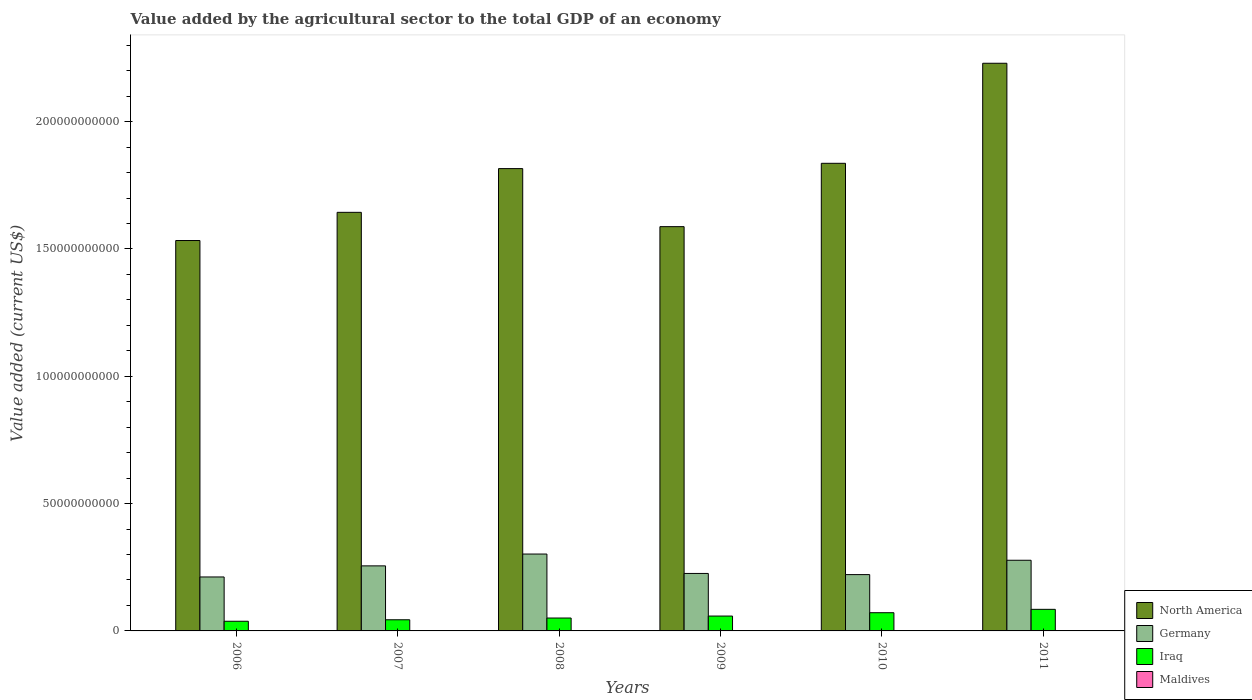How many bars are there on the 3rd tick from the right?
Your answer should be compact. 4. What is the value added by the agricultural sector to the total GDP in Maldives in 2008?
Keep it short and to the point. 1.07e+08. Across all years, what is the maximum value added by the agricultural sector to the total GDP in Iraq?
Provide a succinct answer. 8.48e+09. Across all years, what is the minimum value added by the agricultural sector to the total GDP in Maldives?
Your response must be concise. 8.38e+07. In which year was the value added by the agricultural sector to the total GDP in Germany maximum?
Give a very brief answer. 2008. In which year was the value added by the agricultural sector to the total GDP in North America minimum?
Your response must be concise. 2006. What is the total value added by the agricultural sector to the total GDP in North America in the graph?
Give a very brief answer. 1.06e+12. What is the difference between the value added by the agricultural sector to the total GDP in Germany in 2007 and that in 2010?
Offer a very short reply. 3.43e+09. What is the difference between the value added by the agricultural sector to the total GDP in North America in 2011 and the value added by the agricultural sector to the total GDP in Iraq in 2009?
Provide a succinct answer. 2.17e+11. What is the average value added by the agricultural sector to the total GDP in Iraq per year?
Make the answer very short. 5.78e+09. In the year 2007, what is the difference between the value added by the agricultural sector to the total GDP in Germany and value added by the agricultural sector to the total GDP in North America?
Keep it short and to the point. -1.39e+11. In how many years, is the value added by the agricultural sector to the total GDP in Germany greater than 120000000000 US$?
Provide a succinct answer. 0. What is the ratio of the value added by the agricultural sector to the total GDP in Maldives in 2007 to that in 2008?
Your answer should be compact. 0.81. Is the value added by the agricultural sector to the total GDP in Maldives in 2009 less than that in 2011?
Provide a short and direct response. Yes. What is the difference between the highest and the second highest value added by the agricultural sector to the total GDP in Iraq?
Ensure brevity in your answer.  1.33e+09. What is the difference between the highest and the lowest value added by the agricultural sector to the total GDP in Germany?
Offer a terse response. 9.01e+09. In how many years, is the value added by the agricultural sector to the total GDP in North America greater than the average value added by the agricultural sector to the total GDP in North America taken over all years?
Ensure brevity in your answer.  3. Is the sum of the value added by the agricultural sector to the total GDP in Germany in 2007 and 2011 greater than the maximum value added by the agricultural sector to the total GDP in Iraq across all years?
Your response must be concise. Yes. What does the 4th bar from the left in 2008 represents?
Ensure brevity in your answer.  Maldives. What does the 2nd bar from the right in 2011 represents?
Give a very brief answer. Iraq. Is it the case that in every year, the sum of the value added by the agricultural sector to the total GDP in Maldives and value added by the agricultural sector to the total GDP in Iraq is greater than the value added by the agricultural sector to the total GDP in North America?
Keep it short and to the point. No. How many bars are there?
Offer a very short reply. 24. Are all the bars in the graph horizontal?
Offer a terse response. No. What is the difference between two consecutive major ticks on the Y-axis?
Ensure brevity in your answer.  5.00e+1. Are the values on the major ticks of Y-axis written in scientific E-notation?
Offer a very short reply. No. Does the graph contain grids?
Make the answer very short. No. Where does the legend appear in the graph?
Provide a succinct answer. Bottom right. How are the legend labels stacked?
Make the answer very short. Vertical. What is the title of the graph?
Offer a terse response. Value added by the agricultural sector to the total GDP of an economy. What is the label or title of the X-axis?
Provide a succinct answer. Years. What is the label or title of the Y-axis?
Offer a terse response. Value added (current US$). What is the Value added (current US$) of North America in 2006?
Ensure brevity in your answer.  1.53e+11. What is the Value added (current US$) of Germany in 2006?
Keep it short and to the point. 2.12e+1. What is the Value added (current US$) of Iraq in 2006?
Make the answer very short. 3.80e+09. What is the Value added (current US$) of Maldives in 2006?
Your response must be concise. 8.38e+07. What is the Value added (current US$) in North America in 2007?
Your answer should be very brief. 1.64e+11. What is the Value added (current US$) in Germany in 2007?
Make the answer very short. 2.56e+1. What is the Value added (current US$) of Iraq in 2007?
Provide a succinct answer. 4.38e+09. What is the Value added (current US$) of Maldives in 2007?
Your answer should be very brief. 8.70e+07. What is the Value added (current US$) in North America in 2008?
Give a very brief answer. 1.82e+11. What is the Value added (current US$) of Germany in 2008?
Offer a terse response. 3.02e+1. What is the Value added (current US$) in Iraq in 2008?
Ensure brevity in your answer.  5.06e+09. What is the Value added (current US$) in Maldives in 2008?
Keep it short and to the point. 1.07e+08. What is the Value added (current US$) of North America in 2009?
Provide a short and direct response. 1.59e+11. What is the Value added (current US$) in Germany in 2009?
Give a very brief answer. 2.26e+1. What is the Value added (current US$) of Iraq in 2009?
Provide a short and direct response. 5.84e+09. What is the Value added (current US$) in Maldives in 2009?
Offer a very short reply. 8.56e+07. What is the Value added (current US$) of North America in 2010?
Keep it short and to the point. 1.84e+11. What is the Value added (current US$) of Germany in 2010?
Make the answer very short. 2.21e+1. What is the Value added (current US$) of Iraq in 2010?
Make the answer very short. 7.15e+09. What is the Value added (current US$) in Maldives in 2010?
Make the answer very short. 9.22e+07. What is the Value added (current US$) of North America in 2011?
Keep it short and to the point. 2.23e+11. What is the Value added (current US$) of Germany in 2011?
Ensure brevity in your answer.  2.78e+1. What is the Value added (current US$) of Iraq in 2011?
Provide a short and direct response. 8.48e+09. What is the Value added (current US$) in Maldives in 2011?
Give a very brief answer. 8.92e+07. Across all years, what is the maximum Value added (current US$) of North America?
Your response must be concise. 2.23e+11. Across all years, what is the maximum Value added (current US$) in Germany?
Make the answer very short. 3.02e+1. Across all years, what is the maximum Value added (current US$) in Iraq?
Your answer should be compact. 8.48e+09. Across all years, what is the maximum Value added (current US$) in Maldives?
Your answer should be very brief. 1.07e+08. Across all years, what is the minimum Value added (current US$) in North America?
Keep it short and to the point. 1.53e+11. Across all years, what is the minimum Value added (current US$) in Germany?
Keep it short and to the point. 2.12e+1. Across all years, what is the minimum Value added (current US$) in Iraq?
Provide a succinct answer. 3.80e+09. Across all years, what is the minimum Value added (current US$) in Maldives?
Offer a terse response. 8.38e+07. What is the total Value added (current US$) of North America in the graph?
Ensure brevity in your answer.  1.06e+12. What is the total Value added (current US$) in Germany in the graph?
Your response must be concise. 1.49e+11. What is the total Value added (current US$) in Iraq in the graph?
Your answer should be very brief. 3.47e+1. What is the total Value added (current US$) of Maldives in the graph?
Give a very brief answer. 5.45e+08. What is the difference between the Value added (current US$) in North America in 2006 and that in 2007?
Your answer should be compact. -1.11e+1. What is the difference between the Value added (current US$) in Germany in 2006 and that in 2007?
Ensure brevity in your answer.  -4.36e+09. What is the difference between the Value added (current US$) of Iraq in 2006 and that in 2007?
Give a very brief answer. -5.84e+08. What is the difference between the Value added (current US$) of Maldives in 2006 and that in 2007?
Make the answer very short. -3.25e+06. What is the difference between the Value added (current US$) in North America in 2006 and that in 2008?
Your answer should be compact. -2.82e+1. What is the difference between the Value added (current US$) in Germany in 2006 and that in 2008?
Keep it short and to the point. -9.01e+09. What is the difference between the Value added (current US$) of Iraq in 2006 and that in 2008?
Keep it short and to the point. -1.27e+09. What is the difference between the Value added (current US$) in Maldives in 2006 and that in 2008?
Your answer should be compact. -2.32e+07. What is the difference between the Value added (current US$) of North America in 2006 and that in 2009?
Give a very brief answer. -5.45e+09. What is the difference between the Value added (current US$) in Germany in 2006 and that in 2009?
Offer a very short reply. -1.38e+09. What is the difference between the Value added (current US$) in Iraq in 2006 and that in 2009?
Your response must be concise. -2.04e+09. What is the difference between the Value added (current US$) of Maldives in 2006 and that in 2009?
Give a very brief answer. -1.81e+06. What is the difference between the Value added (current US$) of North America in 2006 and that in 2010?
Make the answer very short. -3.03e+1. What is the difference between the Value added (current US$) of Germany in 2006 and that in 2010?
Offer a terse response. -9.29e+08. What is the difference between the Value added (current US$) in Iraq in 2006 and that in 2010?
Offer a very short reply. -3.36e+09. What is the difference between the Value added (current US$) in Maldives in 2006 and that in 2010?
Your response must be concise. -8.39e+06. What is the difference between the Value added (current US$) of North America in 2006 and that in 2011?
Ensure brevity in your answer.  -6.96e+1. What is the difference between the Value added (current US$) in Germany in 2006 and that in 2011?
Ensure brevity in your answer.  -6.56e+09. What is the difference between the Value added (current US$) in Iraq in 2006 and that in 2011?
Offer a very short reply. -4.68e+09. What is the difference between the Value added (current US$) of Maldives in 2006 and that in 2011?
Offer a terse response. -5.36e+06. What is the difference between the Value added (current US$) in North America in 2007 and that in 2008?
Keep it short and to the point. -1.72e+1. What is the difference between the Value added (current US$) of Germany in 2007 and that in 2008?
Your response must be concise. -4.65e+09. What is the difference between the Value added (current US$) in Iraq in 2007 and that in 2008?
Your answer should be compact. -6.85e+08. What is the difference between the Value added (current US$) in Maldives in 2007 and that in 2008?
Your answer should be very brief. -2.00e+07. What is the difference between the Value added (current US$) in North America in 2007 and that in 2009?
Offer a terse response. 5.62e+09. What is the difference between the Value added (current US$) of Germany in 2007 and that in 2009?
Offer a very short reply. 2.98e+09. What is the difference between the Value added (current US$) of Iraq in 2007 and that in 2009?
Ensure brevity in your answer.  -1.46e+09. What is the difference between the Value added (current US$) of Maldives in 2007 and that in 2009?
Give a very brief answer. 1.43e+06. What is the difference between the Value added (current US$) of North America in 2007 and that in 2010?
Give a very brief answer. -1.93e+1. What is the difference between the Value added (current US$) of Germany in 2007 and that in 2010?
Offer a very short reply. 3.43e+09. What is the difference between the Value added (current US$) in Iraq in 2007 and that in 2010?
Give a very brief answer. -2.77e+09. What is the difference between the Value added (current US$) in Maldives in 2007 and that in 2010?
Make the answer very short. -5.14e+06. What is the difference between the Value added (current US$) of North America in 2007 and that in 2011?
Ensure brevity in your answer.  -5.85e+1. What is the difference between the Value added (current US$) of Germany in 2007 and that in 2011?
Keep it short and to the point. -2.20e+09. What is the difference between the Value added (current US$) in Iraq in 2007 and that in 2011?
Ensure brevity in your answer.  -4.10e+09. What is the difference between the Value added (current US$) of Maldives in 2007 and that in 2011?
Give a very brief answer. -2.12e+06. What is the difference between the Value added (current US$) in North America in 2008 and that in 2009?
Keep it short and to the point. 2.28e+1. What is the difference between the Value added (current US$) of Germany in 2008 and that in 2009?
Offer a very short reply. 7.62e+09. What is the difference between the Value added (current US$) in Iraq in 2008 and that in 2009?
Ensure brevity in your answer.  -7.76e+08. What is the difference between the Value added (current US$) in Maldives in 2008 and that in 2009?
Your response must be concise. 2.14e+07. What is the difference between the Value added (current US$) of North America in 2008 and that in 2010?
Your answer should be very brief. -2.08e+09. What is the difference between the Value added (current US$) of Germany in 2008 and that in 2010?
Your answer should be compact. 8.08e+09. What is the difference between the Value added (current US$) of Iraq in 2008 and that in 2010?
Provide a succinct answer. -2.09e+09. What is the difference between the Value added (current US$) of Maldives in 2008 and that in 2010?
Keep it short and to the point. 1.48e+07. What is the difference between the Value added (current US$) in North America in 2008 and that in 2011?
Keep it short and to the point. -4.14e+1. What is the difference between the Value added (current US$) in Germany in 2008 and that in 2011?
Provide a short and direct response. 2.44e+09. What is the difference between the Value added (current US$) in Iraq in 2008 and that in 2011?
Offer a terse response. -3.41e+09. What is the difference between the Value added (current US$) of Maldives in 2008 and that in 2011?
Make the answer very short. 1.79e+07. What is the difference between the Value added (current US$) in North America in 2009 and that in 2010?
Your answer should be compact. -2.49e+1. What is the difference between the Value added (current US$) in Germany in 2009 and that in 2010?
Provide a short and direct response. 4.54e+08. What is the difference between the Value added (current US$) of Iraq in 2009 and that in 2010?
Your answer should be compact. -1.31e+09. What is the difference between the Value added (current US$) of Maldives in 2009 and that in 2010?
Make the answer very short. -6.58e+06. What is the difference between the Value added (current US$) of North America in 2009 and that in 2011?
Your response must be concise. -6.42e+1. What is the difference between the Value added (current US$) in Germany in 2009 and that in 2011?
Offer a terse response. -5.18e+09. What is the difference between the Value added (current US$) in Iraq in 2009 and that in 2011?
Provide a short and direct response. -2.64e+09. What is the difference between the Value added (current US$) in Maldives in 2009 and that in 2011?
Offer a terse response. -3.55e+06. What is the difference between the Value added (current US$) of North America in 2010 and that in 2011?
Offer a very short reply. -3.93e+1. What is the difference between the Value added (current US$) in Germany in 2010 and that in 2011?
Your answer should be very brief. -5.64e+09. What is the difference between the Value added (current US$) of Iraq in 2010 and that in 2011?
Your response must be concise. -1.33e+09. What is the difference between the Value added (current US$) in Maldives in 2010 and that in 2011?
Offer a very short reply. 3.03e+06. What is the difference between the Value added (current US$) in North America in 2006 and the Value added (current US$) in Germany in 2007?
Keep it short and to the point. 1.28e+11. What is the difference between the Value added (current US$) of North America in 2006 and the Value added (current US$) of Iraq in 2007?
Make the answer very short. 1.49e+11. What is the difference between the Value added (current US$) of North America in 2006 and the Value added (current US$) of Maldives in 2007?
Give a very brief answer. 1.53e+11. What is the difference between the Value added (current US$) in Germany in 2006 and the Value added (current US$) in Iraq in 2007?
Your response must be concise. 1.68e+1. What is the difference between the Value added (current US$) of Germany in 2006 and the Value added (current US$) of Maldives in 2007?
Ensure brevity in your answer.  2.11e+1. What is the difference between the Value added (current US$) in Iraq in 2006 and the Value added (current US$) in Maldives in 2007?
Your answer should be very brief. 3.71e+09. What is the difference between the Value added (current US$) of North America in 2006 and the Value added (current US$) of Germany in 2008?
Your response must be concise. 1.23e+11. What is the difference between the Value added (current US$) of North America in 2006 and the Value added (current US$) of Iraq in 2008?
Give a very brief answer. 1.48e+11. What is the difference between the Value added (current US$) of North America in 2006 and the Value added (current US$) of Maldives in 2008?
Make the answer very short. 1.53e+11. What is the difference between the Value added (current US$) in Germany in 2006 and the Value added (current US$) in Iraq in 2008?
Make the answer very short. 1.61e+1. What is the difference between the Value added (current US$) in Germany in 2006 and the Value added (current US$) in Maldives in 2008?
Your response must be concise. 2.11e+1. What is the difference between the Value added (current US$) of Iraq in 2006 and the Value added (current US$) of Maldives in 2008?
Keep it short and to the point. 3.69e+09. What is the difference between the Value added (current US$) of North America in 2006 and the Value added (current US$) of Germany in 2009?
Offer a very short reply. 1.31e+11. What is the difference between the Value added (current US$) of North America in 2006 and the Value added (current US$) of Iraq in 2009?
Your answer should be very brief. 1.47e+11. What is the difference between the Value added (current US$) of North America in 2006 and the Value added (current US$) of Maldives in 2009?
Give a very brief answer. 1.53e+11. What is the difference between the Value added (current US$) of Germany in 2006 and the Value added (current US$) of Iraq in 2009?
Your answer should be very brief. 1.54e+1. What is the difference between the Value added (current US$) in Germany in 2006 and the Value added (current US$) in Maldives in 2009?
Your answer should be very brief. 2.11e+1. What is the difference between the Value added (current US$) in Iraq in 2006 and the Value added (current US$) in Maldives in 2009?
Your answer should be compact. 3.71e+09. What is the difference between the Value added (current US$) in North America in 2006 and the Value added (current US$) in Germany in 2010?
Give a very brief answer. 1.31e+11. What is the difference between the Value added (current US$) of North America in 2006 and the Value added (current US$) of Iraq in 2010?
Give a very brief answer. 1.46e+11. What is the difference between the Value added (current US$) in North America in 2006 and the Value added (current US$) in Maldives in 2010?
Make the answer very short. 1.53e+11. What is the difference between the Value added (current US$) of Germany in 2006 and the Value added (current US$) of Iraq in 2010?
Offer a terse response. 1.40e+1. What is the difference between the Value added (current US$) of Germany in 2006 and the Value added (current US$) of Maldives in 2010?
Keep it short and to the point. 2.11e+1. What is the difference between the Value added (current US$) in Iraq in 2006 and the Value added (current US$) in Maldives in 2010?
Offer a terse response. 3.70e+09. What is the difference between the Value added (current US$) of North America in 2006 and the Value added (current US$) of Germany in 2011?
Your answer should be very brief. 1.26e+11. What is the difference between the Value added (current US$) of North America in 2006 and the Value added (current US$) of Iraq in 2011?
Keep it short and to the point. 1.45e+11. What is the difference between the Value added (current US$) of North America in 2006 and the Value added (current US$) of Maldives in 2011?
Offer a terse response. 1.53e+11. What is the difference between the Value added (current US$) in Germany in 2006 and the Value added (current US$) in Iraq in 2011?
Ensure brevity in your answer.  1.27e+1. What is the difference between the Value added (current US$) of Germany in 2006 and the Value added (current US$) of Maldives in 2011?
Ensure brevity in your answer.  2.11e+1. What is the difference between the Value added (current US$) of Iraq in 2006 and the Value added (current US$) of Maldives in 2011?
Your response must be concise. 3.71e+09. What is the difference between the Value added (current US$) in North America in 2007 and the Value added (current US$) in Germany in 2008?
Give a very brief answer. 1.34e+11. What is the difference between the Value added (current US$) of North America in 2007 and the Value added (current US$) of Iraq in 2008?
Make the answer very short. 1.59e+11. What is the difference between the Value added (current US$) in North America in 2007 and the Value added (current US$) in Maldives in 2008?
Make the answer very short. 1.64e+11. What is the difference between the Value added (current US$) in Germany in 2007 and the Value added (current US$) in Iraq in 2008?
Your answer should be very brief. 2.05e+1. What is the difference between the Value added (current US$) of Germany in 2007 and the Value added (current US$) of Maldives in 2008?
Offer a terse response. 2.54e+1. What is the difference between the Value added (current US$) in Iraq in 2007 and the Value added (current US$) in Maldives in 2008?
Your answer should be compact. 4.27e+09. What is the difference between the Value added (current US$) of North America in 2007 and the Value added (current US$) of Germany in 2009?
Offer a very short reply. 1.42e+11. What is the difference between the Value added (current US$) of North America in 2007 and the Value added (current US$) of Iraq in 2009?
Your answer should be very brief. 1.59e+11. What is the difference between the Value added (current US$) of North America in 2007 and the Value added (current US$) of Maldives in 2009?
Give a very brief answer. 1.64e+11. What is the difference between the Value added (current US$) of Germany in 2007 and the Value added (current US$) of Iraq in 2009?
Keep it short and to the point. 1.97e+1. What is the difference between the Value added (current US$) in Germany in 2007 and the Value added (current US$) in Maldives in 2009?
Offer a very short reply. 2.55e+1. What is the difference between the Value added (current US$) of Iraq in 2007 and the Value added (current US$) of Maldives in 2009?
Provide a short and direct response. 4.29e+09. What is the difference between the Value added (current US$) of North America in 2007 and the Value added (current US$) of Germany in 2010?
Your answer should be compact. 1.42e+11. What is the difference between the Value added (current US$) of North America in 2007 and the Value added (current US$) of Iraq in 2010?
Keep it short and to the point. 1.57e+11. What is the difference between the Value added (current US$) in North America in 2007 and the Value added (current US$) in Maldives in 2010?
Keep it short and to the point. 1.64e+11. What is the difference between the Value added (current US$) of Germany in 2007 and the Value added (current US$) of Iraq in 2010?
Your response must be concise. 1.84e+1. What is the difference between the Value added (current US$) in Germany in 2007 and the Value added (current US$) in Maldives in 2010?
Your answer should be very brief. 2.55e+1. What is the difference between the Value added (current US$) in Iraq in 2007 and the Value added (current US$) in Maldives in 2010?
Your answer should be very brief. 4.29e+09. What is the difference between the Value added (current US$) in North America in 2007 and the Value added (current US$) in Germany in 2011?
Your response must be concise. 1.37e+11. What is the difference between the Value added (current US$) of North America in 2007 and the Value added (current US$) of Iraq in 2011?
Offer a very short reply. 1.56e+11. What is the difference between the Value added (current US$) of North America in 2007 and the Value added (current US$) of Maldives in 2011?
Your response must be concise. 1.64e+11. What is the difference between the Value added (current US$) in Germany in 2007 and the Value added (current US$) in Iraq in 2011?
Your answer should be compact. 1.71e+1. What is the difference between the Value added (current US$) in Germany in 2007 and the Value added (current US$) in Maldives in 2011?
Ensure brevity in your answer.  2.55e+1. What is the difference between the Value added (current US$) in Iraq in 2007 and the Value added (current US$) in Maldives in 2011?
Provide a short and direct response. 4.29e+09. What is the difference between the Value added (current US$) of North America in 2008 and the Value added (current US$) of Germany in 2009?
Provide a succinct answer. 1.59e+11. What is the difference between the Value added (current US$) in North America in 2008 and the Value added (current US$) in Iraq in 2009?
Your response must be concise. 1.76e+11. What is the difference between the Value added (current US$) in North America in 2008 and the Value added (current US$) in Maldives in 2009?
Offer a terse response. 1.81e+11. What is the difference between the Value added (current US$) in Germany in 2008 and the Value added (current US$) in Iraq in 2009?
Provide a short and direct response. 2.44e+1. What is the difference between the Value added (current US$) of Germany in 2008 and the Value added (current US$) of Maldives in 2009?
Make the answer very short. 3.01e+1. What is the difference between the Value added (current US$) of Iraq in 2008 and the Value added (current US$) of Maldives in 2009?
Ensure brevity in your answer.  4.98e+09. What is the difference between the Value added (current US$) in North America in 2008 and the Value added (current US$) in Germany in 2010?
Keep it short and to the point. 1.59e+11. What is the difference between the Value added (current US$) in North America in 2008 and the Value added (current US$) in Iraq in 2010?
Ensure brevity in your answer.  1.74e+11. What is the difference between the Value added (current US$) in North America in 2008 and the Value added (current US$) in Maldives in 2010?
Ensure brevity in your answer.  1.81e+11. What is the difference between the Value added (current US$) of Germany in 2008 and the Value added (current US$) of Iraq in 2010?
Provide a succinct answer. 2.30e+1. What is the difference between the Value added (current US$) in Germany in 2008 and the Value added (current US$) in Maldives in 2010?
Keep it short and to the point. 3.01e+1. What is the difference between the Value added (current US$) of Iraq in 2008 and the Value added (current US$) of Maldives in 2010?
Your response must be concise. 4.97e+09. What is the difference between the Value added (current US$) in North America in 2008 and the Value added (current US$) in Germany in 2011?
Provide a short and direct response. 1.54e+11. What is the difference between the Value added (current US$) in North America in 2008 and the Value added (current US$) in Iraq in 2011?
Give a very brief answer. 1.73e+11. What is the difference between the Value added (current US$) in North America in 2008 and the Value added (current US$) in Maldives in 2011?
Your response must be concise. 1.81e+11. What is the difference between the Value added (current US$) of Germany in 2008 and the Value added (current US$) of Iraq in 2011?
Your response must be concise. 2.17e+1. What is the difference between the Value added (current US$) in Germany in 2008 and the Value added (current US$) in Maldives in 2011?
Give a very brief answer. 3.01e+1. What is the difference between the Value added (current US$) of Iraq in 2008 and the Value added (current US$) of Maldives in 2011?
Offer a very short reply. 4.98e+09. What is the difference between the Value added (current US$) of North America in 2009 and the Value added (current US$) of Germany in 2010?
Ensure brevity in your answer.  1.37e+11. What is the difference between the Value added (current US$) in North America in 2009 and the Value added (current US$) in Iraq in 2010?
Your response must be concise. 1.52e+11. What is the difference between the Value added (current US$) of North America in 2009 and the Value added (current US$) of Maldives in 2010?
Your response must be concise. 1.59e+11. What is the difference between the Value added (current US$) of Germany in 2009 and the Value added (current US$) of Iraq in 2010?
Your answer should be compact. 1.54e+1. What is the difference between the Value added (current US$) of Germany in 2009 and the Value added (current US$) of Maldives in 2010?
Offer a terse response. 2.25e+1. What is the difference between the Value added (current US$) of Iraq in 2009 and the Value added (current US$) of Maldives in 2010?
Ensure brevity in your answer.  5.75e+09. What is the difference between the Value added (current US$) of North America in 2009 and the Value added (current US$) of Germany in 2011?
Your response must be concise. 1.31e+11. What is the difference between the Value added (current US$) in North America in 2009 and the Value added (current US$) in Iraq in 2011?
Provide a short and direct response. 1.50e+11. What is the difference between the Value added (current US$) in North America in 2009 and the Value added (current US$) in Maldives in 2011?
Offer a very short reply. 1.59e+11. What is the difference between the Value added (current US$) in Germany in 2009 and the Value added (current US$) in Iraq in 2011?
Offer a very short reply. 1.41e+1. What is the difference between the Value added (current US$) of Germany in 2009 and the Value added (current US$) of Maldives in 2011?
Your answer should be compact. 2.25e+1. What is the difference between the Value added (current US$) of Iraq in 2009 and the Value added (current US$) of Maldives in 2011?
Keep it short and to the point. 5.75e+09. What is the difference between the Value added (current US$) in North America in 2010 and the Value added (current US$) in Germany in 2011?
Keep it short and to the point. 1.56e+11. What is the difference between the Value added (current US$) in North America in 2010 and the Value added (current US$) in Iraq in 2011?
Your response must be concise. 1.75e+11. What is the difference between the Value added (current US$) in North America in 2010 and the Value added (current US$) in Maldives in 2011?
Ensure brevity in your answer.  1.84e+11. What is the difference between the Value added (current US$) in Germany in 2010 and the Value added (current US$) in Iraq in 2011?
Your answer should be compact. 1.36e+1. What is the difference between the Value added (current US$) of Germany in 2010 and the Value added (current US$) of Maldives in 2011?
Your response must be concise. 2.20e+1. What is the difference between the Value added (current US$) in Iraq in 2010 and the Value added (current US$) in Maldives in 2011?
Offer a very short reply. 7.06e+09. What is the average Value added (current US$) in North America per year?
Offer a terse response. 1.77e+11. What is the average Value added (current US$) in Germany per year?
Offer a terse response. 2.49e+1. What is the average Value added (current US$) in Iraq per year?
Ensure brevity in your answer.  5.78e+09. What is the average Value added (current US$) in Maldives per year?
Offer a terse response. 9.08e+07. In the year 2006, what is the difference between the Value added (current US$) in North America and Value added (current US$) in Germany?
Your response must be concise. 1.32e+11. In the year 2006, what is the difference between the Value added (current US$) of North America and Value added (current US$) of Iraq?
Give a very brief answer. 1.50e+11. In the year 2006, what is the difference between the Value added (current US$) in North America and Value added (current US$) in Maldives?
Your answer should be compact. 1.53e+11. In the year 2006, what is the difference between the Value added (current US$) in Germany and Value added (current US$) in Iraq?
Your response must be concise. 1.74e+1. In the year 2006, what is the difference between the Value added (current US$) of Germany and Value added (current US$) of Maldives?
Your answer should be compact. 2.11e+1. In the year 2006, what is the difference between the Value added (current US$) in Iraq and Value added (current US$) in Maldives?
Give a very brief answer. 3.71e+09. In the year 2007, what is the difference between the Value added (current US$) of North America and Value added (current US$) of Germany?
Your answer should be very brief. 1.39e+11. In the year 2007, what is the difference between the Value added (current US$) of North America and Value added (current US$) of Iraq?
Offer a terse response. 1.60e+11. In the year 2007, what is the difference between the Value added (current US$) of North America and Value added (current US$) of Maldives?
Your answer should be very brief. 1.64e+11. In the year 2007, what is the difference between the Value added (current US$) of Germany and Value added (current US$) of Iraq?
Your answer should be very brief. 2.12e+1. In the year 2007, what is the difference between the Value added (current US$) in Germany and Value added (current US$) in Maldives?
Keep it short and to the point. 2.55e+1. In the year 2007, what is the difference between the Value added (current US$) of Iraq and Value added (current US$) of Maldives?
Ensure brevity in your answer.  4.29e+09. In the year 2008, what is the difference between the Value added (current US$) in North America and Value added (current US$) in Germany?
Make the answer very short. 1.51e+11. In the year 2008, what is the difference between the Value added (current US$) in North America and Value added (current US$) in Iraq?
Your answer should be compact. 1.77e+11. In the year 2008, what is the difference between the Value added (current US$) in North America and Value added (current US$) in Maldives?
Make the answer very short. 1.81e+11. In the year 2008, what is the difference between the Value added (current US$) of Germany and Value added (current US$) of Iraq?
Your answer should be compact. 2.51e+1. In the year 2008, what is the difference between the Value added (current US$) in Germany and Value added (current US$) in Maldives?
Your response must be concise. 3.01e+1. In the year 2008, what is the difference between the Value added (current US$) in Iraq and Value added (current US$) in Maldives?
Your response must be concise. 4.96e+09. In the year 2009, what is the difference between the Value added (current US$) of North America and Value added (current US$) of Germany?
Offer a terse response. 1.36e+11. In the year 2009, what is the difference between the Value added (current US$) in North America and Value added (current US$) in Iraq?
Offer a very short reply. 1.53e+11. In the year 2009, what is the difference between the Value added (current US$) in North America and Value added (current US$) in Maldives?
Keep it short and to the point. 1.59e+11. In the year 2009, what is the difference between the Value added (current US$) of Germany and Value added (current US$) of Iraq?
Your response must be concise. 1.67e+1. In the year 2009, what is the difference between the Value added (current US$) in Germany and Value added (current US$) in Maldives?
Offer a terse response. 2.25e+1. In the year 2009, what is the difference between the Value added (current US$) in Iraq and Value added (current US$) in Maldives?
Keep it short and to the point. 5.75e+09. In the year 2010, what is the difference between the Value added (current US$) in North America and Value added (current US$) in Germany?
Provide a succinct answer. 1.62e+11. In the year 2010, what is the difference between the Value added (current US$) of North America and Value added (current US$) of Iraq?
Ensure brevity in your answer.  1.77e+11. In the year 2010, what is the difference between the Value added (current US$) in North America and Value added (current US$) in Maldives?
Your answer should be very brief. 1.84e+11. In the year 2010, what is the difference between the Value added (current US$) in Germany and Value added (current US$) in Iraq?
Your answer should be compact. 1.50e+1. In the year 2010, what is the difference between the Value added (current US$) in Germany and Value added (current US$) in Maldives?
Provide a short and direct response. 2.20e+1. In the year 2010, what is the difference between the Value added (current US$) of Iraq and Value added (current US$) of Maldives?
Ensure brevity in your answer.  7.06e+09. In the year 2011, what is the difference between the Value added (current US$) of North America and Value added (current US$) of Germany?
Your answer should be compact. 1.95e+11. In the year 2011, what is the difference between the Value added (current US$) of North America and Value added (current US$) of Iraq?
Keep it short and to the point. 2.14e+11. In the year 2011, what is the difference between the Value added (current US$) in North America and Value added (current US$) in Maldives?
Your response must be concise. 2.23e+11. In the year 2011, what is the difference between the Value added (current US$) in Germany and Value added (current US$) in Iraq?
Give a very brief answer. 1.93e+1. In the year 2011, what is the difference between the Value added (current US$) in Germany and Value added (current US$) in Maldives?
Give a very brief answer. 2.77e+1. In the year 2011, what is the difference between the Value added (current US$) in Iraq and Value added (current US$) in Maldives?
Keep it short and to the point. 8.39e+09. What is the ratio of the Value added (current US$) of North America in 2006 to that in 2007?
Ensure brevity in your answer.  0.93. What is the ratio of the Value added (current US$) in Germany in 2006 to that in 2007?
Your answer should be very brief. 0.83. What is the ratio of the Value added (current US$) of Iraq in 2006 to that in 2007?
Give a very brief answer. 0.87. What is the ratio of the Value added (current US$) of Maldives in 2006 to that in 2007?
Keep it short and to the point. 0.96. What is the ratio of the Value added (current US$) of North America in 2006 to that in 2008?
Your answer should be very brief. 0.84. What is the ratio of the Value added (current US$) in Germany in 2006 to that in 2008?
Give a very brief answer. 0.7. What is the ratio of the Value added (current US$) of Iraq in 2006 to that in 2008?
Provide a short and direct response. 0.75. What is the ratio of the Value added (current US$) in Maldives in 2006 to that in 2008?
Make the answer very short. 0.78. What is the ratio of the Value added (current US$) in North America in 2006 to that in 2009?
Provide a succinct answer. 0.97. What is the ratio of the Value added (current US$) in Germany in 2006 to that in 2009?
Make the answer very short. 0.94. What is the ratio of the Value added (current US$) in Iraq in 2006 to that in 2009?
Your answer should be very brief. 0.65. What is the ratio of the Value added (current US$) in Maldives in 2006 to that in 2009?
Your answer should be very brief. 0.98. What is the ratio of the Value added (current US$) in North America in 2006 to that in 2010?
Offer a very short reply. 0.83. What is the ratio of the Value added (current US$) in Germany in 2006 to that in 2010?
Give a very brief answer. 0.96. What is the ratio of the Value added (current US$) of Iraq in 2006 to that in 2010?
Make the answer very short. 0.53. What is the ratio of the Value added (current US$) in Maldives in 2006 to that in 2010?
Offer a terse response. 0.91. What is the ratio of the Value added (current US$) in North America in 2006 to that in 2011?
Your response must be concise. 0.69. What is the ratio of the Value added (current US$) in Germany in 2006 to that in 2011?
Provide a succinct answer. 0.76. What is the ratio of the Value added (current US$) in Iraq in 2006 to that in 2011?
Your response must be concise. 0.45. What is the ratio of the Value added (current US$) of Maldives in 2006 to that in 2011?
Provide a succinct answer. 0.94. What is the ratio of the Value added (current US$) in North America in 2007 to that in 2008?
Provide a short and direct response. 0.91. What is the ratio of the Value added (current US$) of Germany in 2007 to that in 2008?
Provide a succinct answer. 0.85. What is the ratio of the Value added (current US$) of Iraq in 2007 to that in 2008?
Your answer should be very brief. 0.86. What is the ratio of the Value added (current US$) in Maldives in 2007 to that in 2008?
Offer a terse response. 0.81. What is the ratio of the Value added (current US$) of North America in 2007 to that in 2009?
Keep it short and to the point. 1.04. What is the ratio of the Value added (current US$) in Germany in 2007 to that in 2009?
Ensure brevity in your answer.  1.13. What is the ratio of the Value added (current US$) of Iraq in 2007 to that in 2009?
Offer a terse response. 0.75. What is the ratio of the Value added (current US$) of Maldives in 2007 to that in 2009?
Keep it short and to the point. 1.02. What is the ratio of the Value added (current US$) of North America in 2007 to that in 2010?
Offer a very short reply. 0.9. What is the ratio of the Value added (current US$) of Germany in 2007 to that in 2010?
Offer a very short reply. 1.16. What is the ratio of the Value added (current US$) in Iraq in 2007 to that in 2010?
Keep it short and to the point. 0.61. What is the ratio of the Value added (current US$) of Maldives in 2007 to that in 2010?
Ensure brevity in your answer.  0.94. What is the ratio of the Value added (current US$) of North America in 2007 to that in 2011?
Your answer should be very brief. 0.74. What is the ratio of the Value added (current US$) in Germany in 2007 to that in 2011?
Keep it short and to the point. 0.92. What is the ratio of the Value added (current US$) in Iraq in 2007 to that in 2011?
Your response must be concise. 0.52. What is the ratio of the Value added (current US$) in Maldives in 2007 to that in 2011?
Ensure brevity in your answer.  0.98. What is the ratio of the Value added (current US$) in North America in 2008 to that in 2009?
Your response must be concise. 1.14. What is the ratio of the Value added (current US$) in Germany in 2008 to that in 2009?
Provide a succinct answer. 1.34. What is the ratio of the Value added (current US$) in Iraq in 2008 to that in 2009?
Keep it short and to the point. 0.87. What is the ratio of the Value added (current US$) of Maldives in 2008 to that in 2009?
Your response must be concise. 1.25. What is the ratio of the Value added (current US$) in North America in 2008 to that in 2010?
Keep it short and to the point. 0.99. What is the ratio of the Value added (current US$) in Germany in 2008 to that in 2010?
Keep it short and to the point. 1.37. What is the ratio of the Value added (current US$) in Iraq in 2008 to that in 2010?
Keep it short and to the point. 0.71. What is the ratio of the Value added (current US$) in Maldives in 2008 to that in 2010?
Keep it short and to the point. 1.16. What is the ratio of the Value added (current US$) in North America in 2008 to that in 2011?
Your response must be concise. 0.81. What is the ratio of the Value added (current US$) in Germany in 2008 to that in 2011?
Your response must be concise. 1.09. What is the ratio of the Value added (current US$) in Iraq in 2008 to that in 2011?
Your answer should be compact. 0.6. What is the ratio of the Value added (current US$) in Maldives in 2008 to that in 2011?
Offer a terse response. 1.2. What is the ratio of the Value added (current US$) of North America in 2009 to that in 2010?
Provide a short and direct response. 0.86. What is the ratio of the Value added (current US$) of Germany in 2009 to that in 2010?
Your response must be concise. 1.02. What is the ratio of the Value added (current US$) of Iraq in 2009 to that in 2010?
Your answer should be very brief. 0.82. What is the ratio of the Value added (current US$) in Maldives in 2009 to that in 2010?
Offer a very short reply. 0.93. What is the ratio of the Value added (current US$) in North America in 2009 to that in 2011?
Offer a very short reply. 0.71. What is the ratio of the Value added (current US$) of Germany in 2009 to that in 2011?
Provide a succinct answer. 0.81. What is the ratio of the Value added (current US$) in Iraq in 2009 to that in 2011?
Provide a short and direct response. 0.69. What is the ratio of the Value added (current US$) of Maldives in 2009 to that in 2011?
Your answer should be compact. 0.96. What is the ratio of the Value added (current US$) of North America in 2010 to that in 2011?
Make the answer very short. 0.82. What is the ratio of the Value added (current US$) of Germany in 2010 to that in 2011?
Give a very brief answer. 0.8. What is the ratio of the Value added (current US$) in Iraq in 2010 to that in 2011?
Offer a terse response. 0.84. What is the ratio of the Value added (current US$) of Maldives in 2010 to that in 2011?
Offer a very short reply. 1.03. What is the difference between the highest and the second highest Value added (current US$) in North America?
Your answer should be very brief. 3.93e+1. What is the difference between the highest and the second highest Value added (current US$) of Germany?
Your answer should be very brief. 2.44e+09. What is the difference between the highest and the second highest Value added (current US$) of Iraq?
Your answer should be compact. 1.33e+09. What is the difference between the highest and the second highest Value added (current US$) in Maldives?
Make the answer very short. 1.48e+07. What is the difference between the highest and the lowest Value added (current US$) in North America?
Your response must be concise. 6.96e+1. What is the difference between the highest and the lowest Value added (current US$) in Germany?
Provide a succinct answer. 9.01e+09. What is the difference between the highest and the lowest Value added (current US$) of Iraq?
Offer a very short reply. 4.68e+09. What is the difference between the highest and the lowest Value added (current US$) of Maldives?
Your response must be concise. 2.32e+07. 